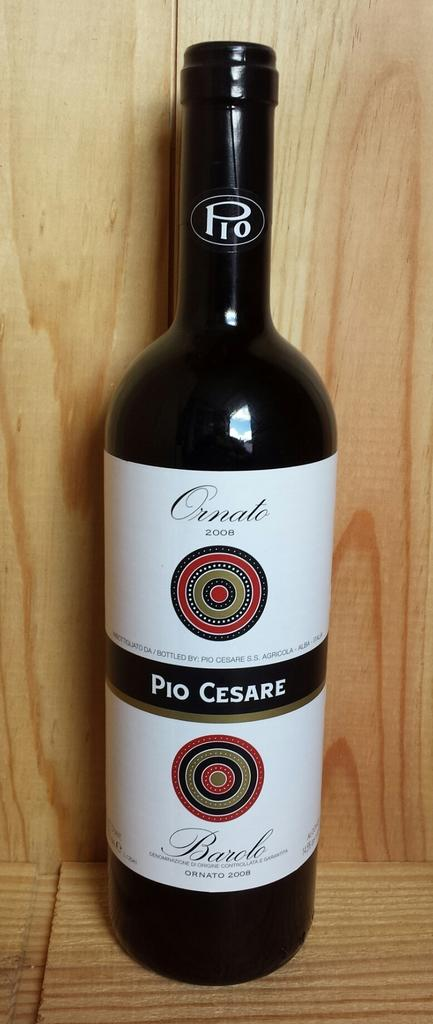<image>
Summarize the visual content of the image. A bottle of Ornate Pio Cesare wine sitting on a table. 